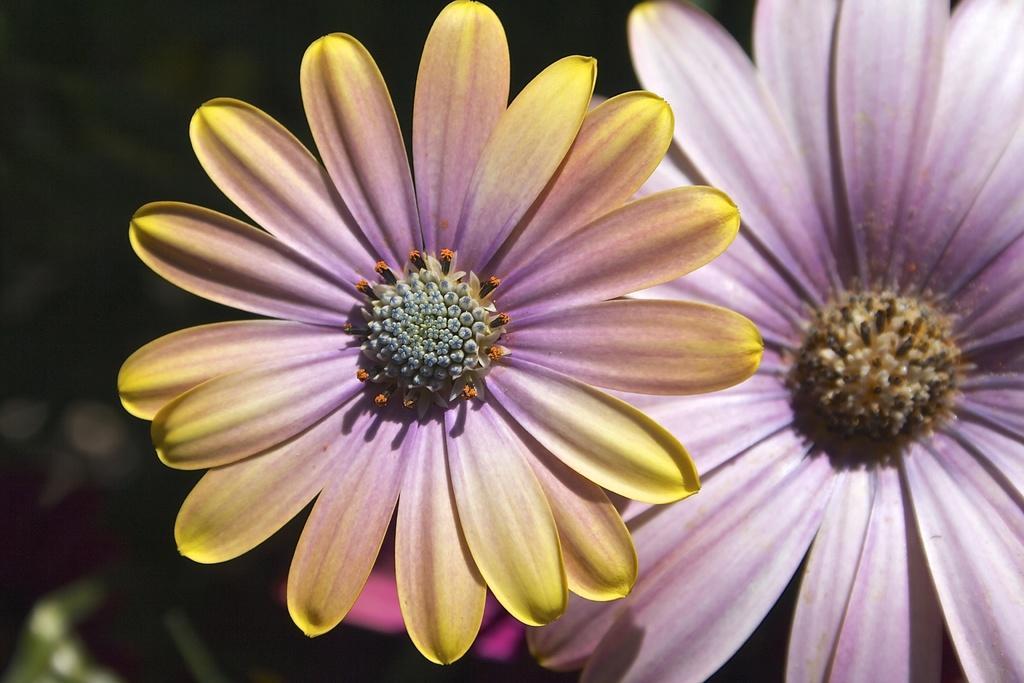Can you describe this image briefly? This picture shows couple of flowers. 